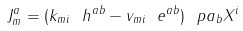Convert formula to latex. <formula><loc_0><loc_0><loc_500><loc_500>J ^ { a } _ { m } = ( k _ { m i } \ h ^ { a b } - v _ { m i } \ e ^ { a b } ) \ p a _ { b } X ^ { i }</formula> 